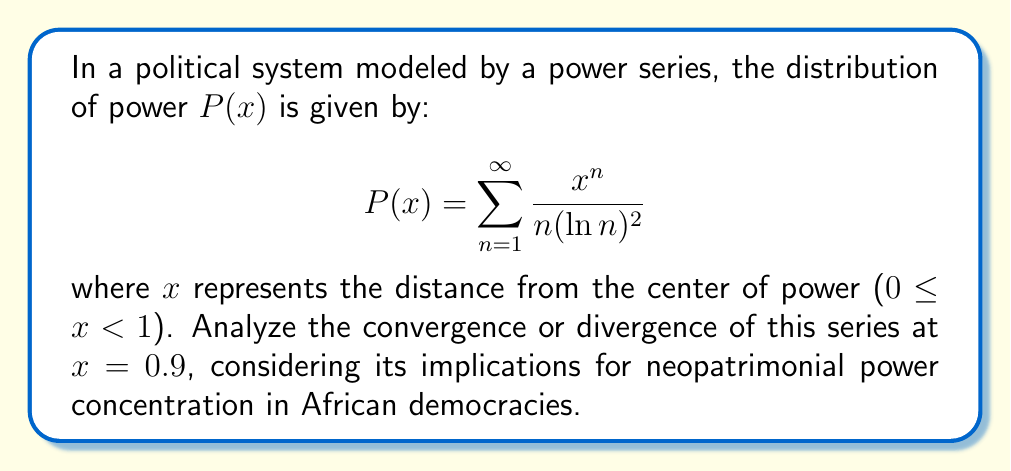Teach me how to tackle this problem. To analyze the convergence of this power series at x = 0.9, we'll use the ratio test:

1) First, let's define the general term of the series:
   $$a_n = \frac{(0.9)^n}{n(\ln n)^2}$$

2) Now, we'll calculate the limit of the ratio of successive terms:
   $$\lim_{n \to \infty} \left|\frac{a_{n+1}}{a_n}\right| = \lim_{n \to \infty} \left|\frac{\frac{(0.9)^{n+1}}{(n+1)(\ln(n+1))^2}}{\frac{(0.9)^n}{n(\ln n)^2}}\right|$$

3) Simplify:
   $$= \lim_{n \to \infty} \left|0.9 \cdot \frac{n}{n+1} \cdot \frac{(\ln n)^2}{(\ln(n+1))^2}\right|$$

4) As n approaches infinity:
   - $\frac{n}{n+1}$ approaches 1
   - $\frac{(\ln n)^2}{(\ln(n+1))^2}$ also approaches 1

5) Therefore:
   $$\lim_{n \to \infty} \left|\frac{a_{n+1}}{a_n}\right| = 0.9 < 1$$

6) Since the limit is less than 1, by the ratio test, the series converges at x = 0.9.

In the context of neopatrimonialism in African democracies, this convergence suggests that power distribution remains finite even at a significant distance (0.9) from the center. This implies a degree of power decentralization, potentially indicating a more democratic structure despite neopatrimonial influences.
Answer: The series converges at x = 0.9. 